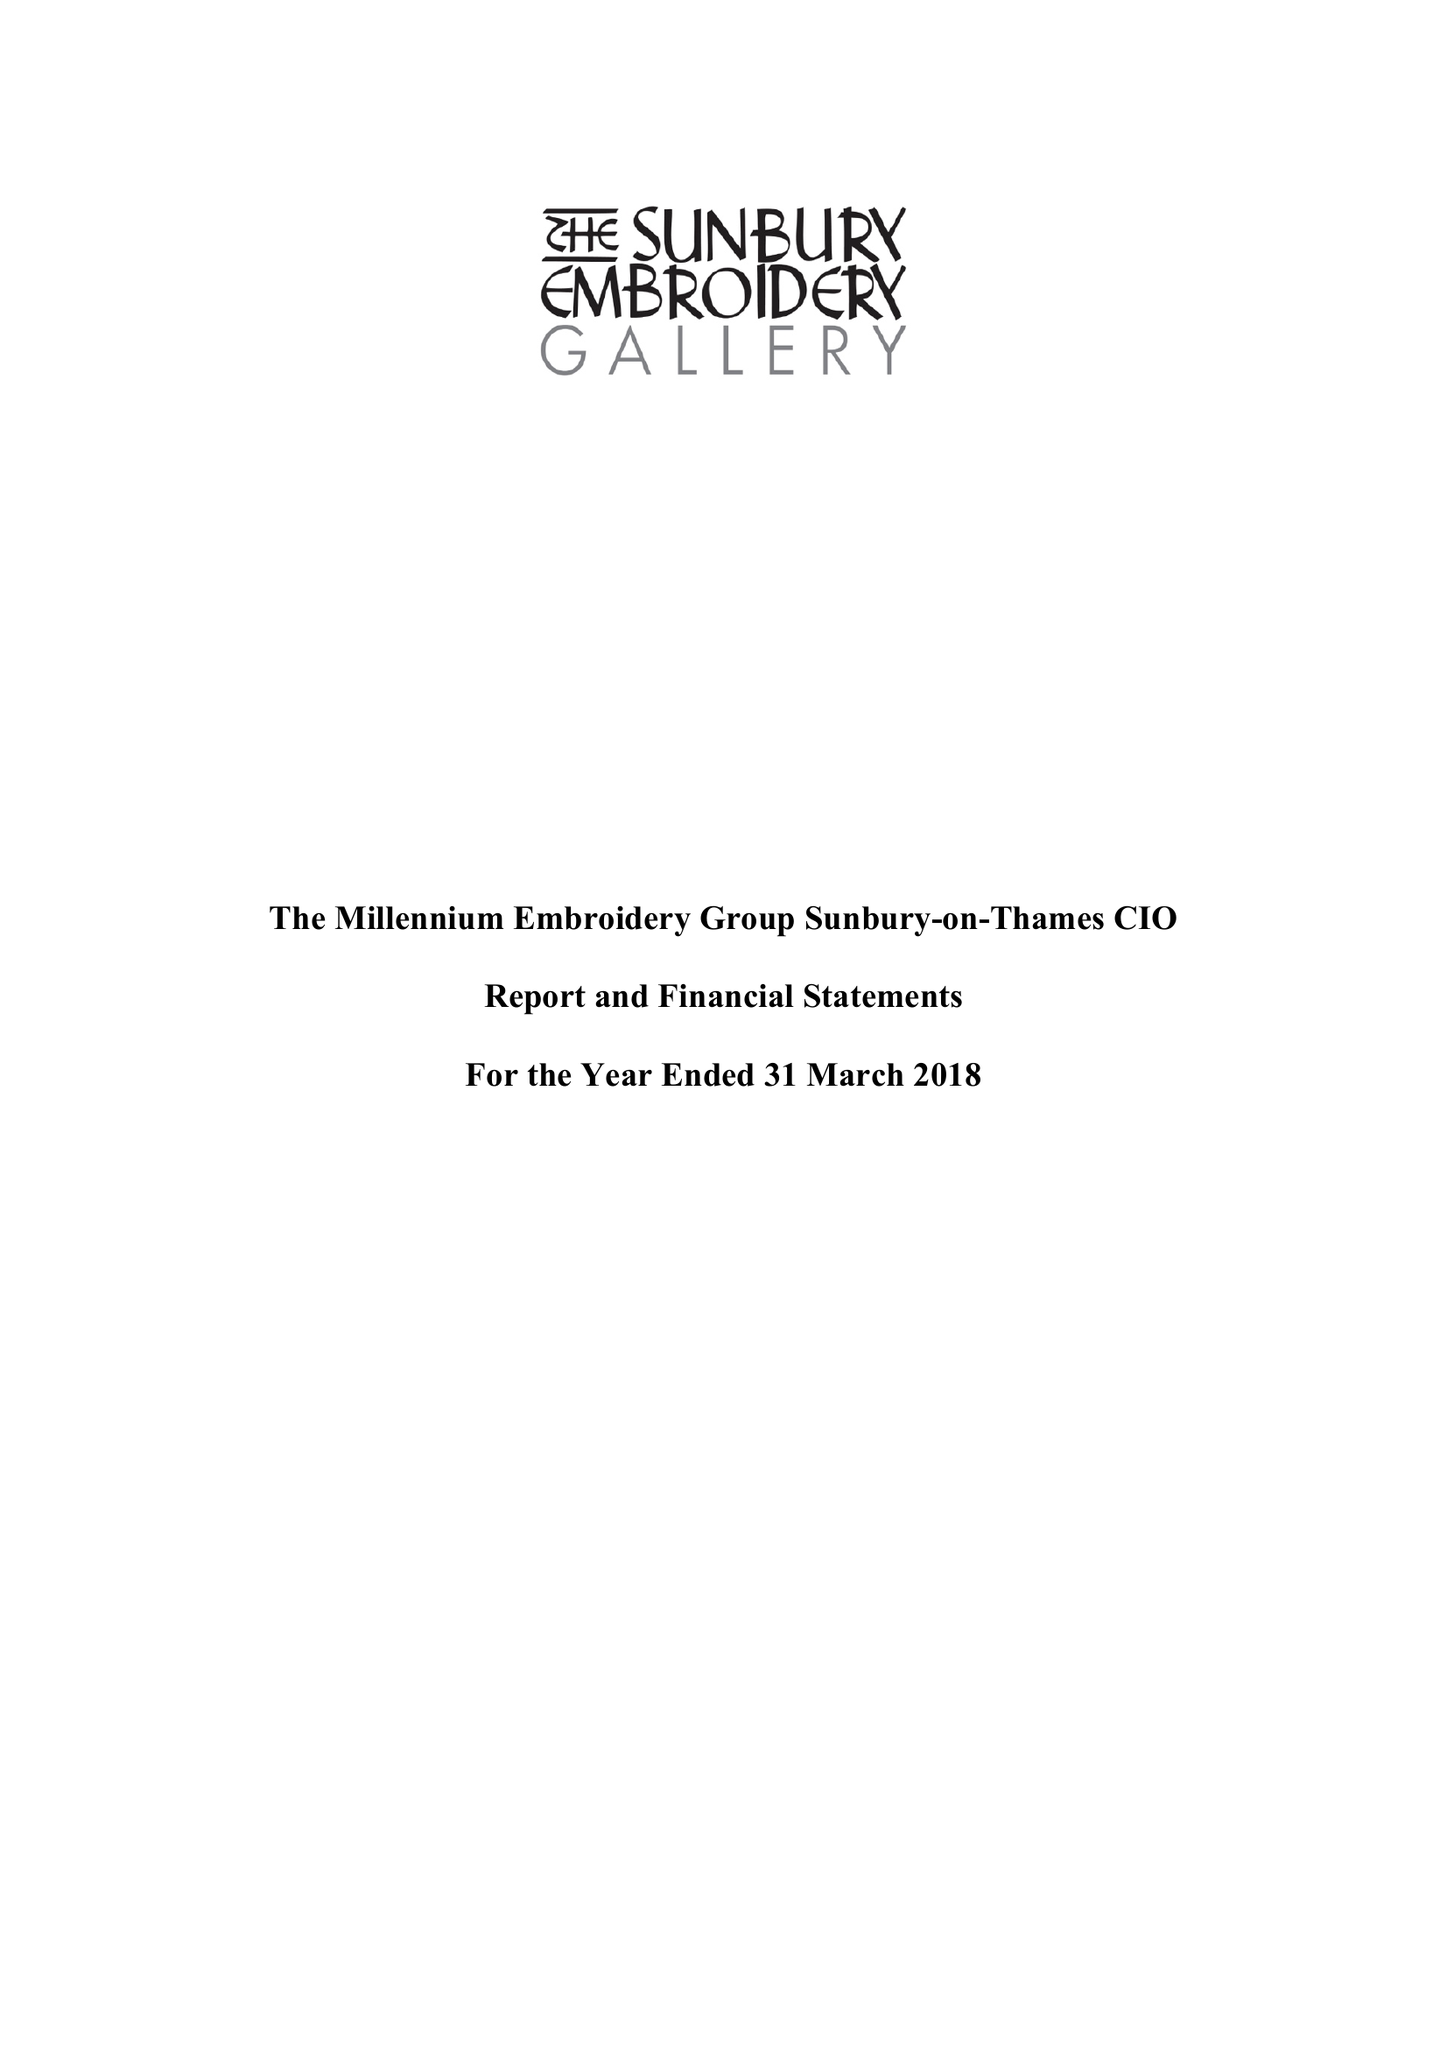What is the value for the charity_number?
Answer the question using a single word or phrase. 1162121 